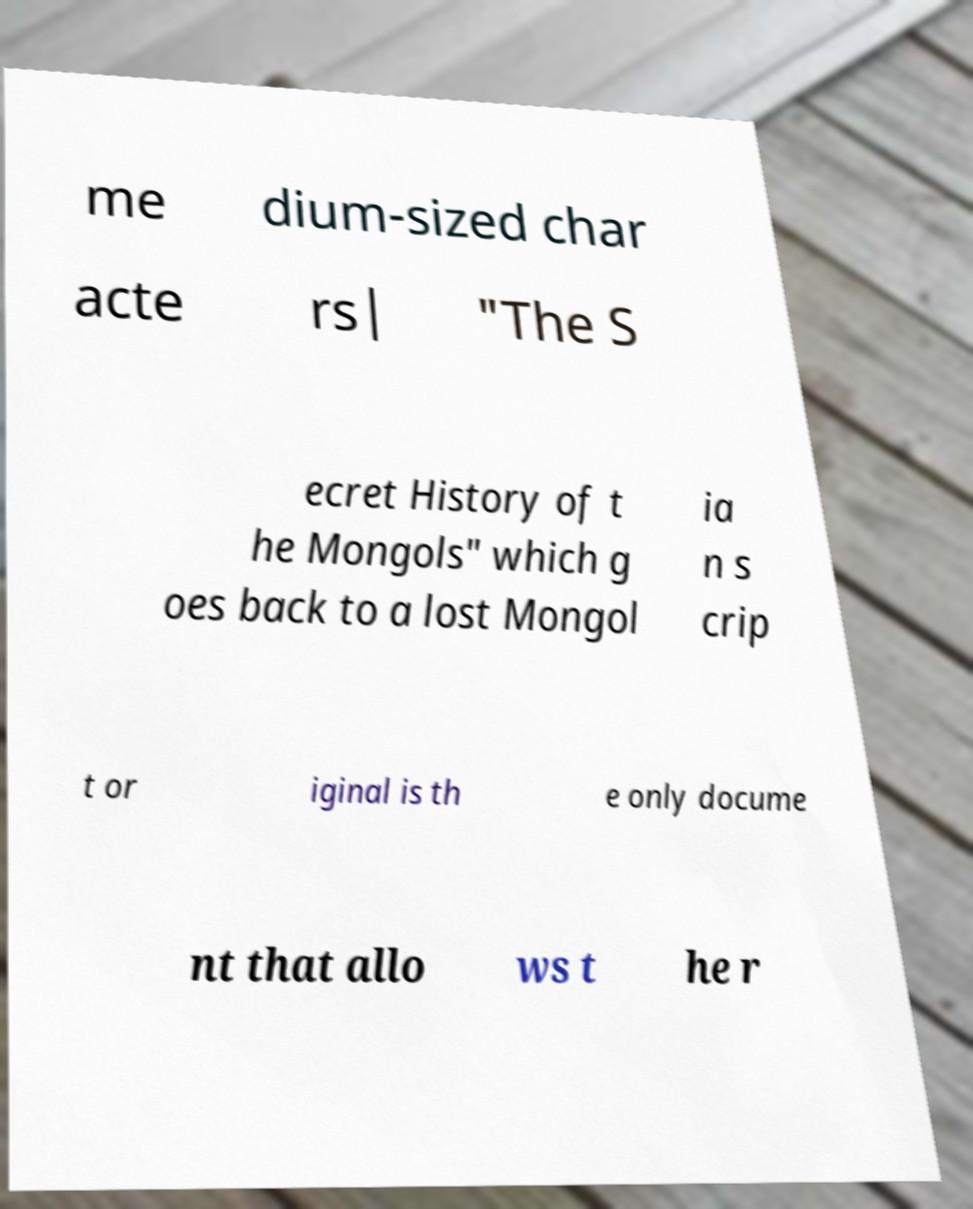Could you extract and type out the text from this image? me dium-sized char acte rs| "The S ecret History of t he Mongols" which g oes back to a lost Mongol ia n s crip t or iginal is th e only docume nt that allo ws t he r 